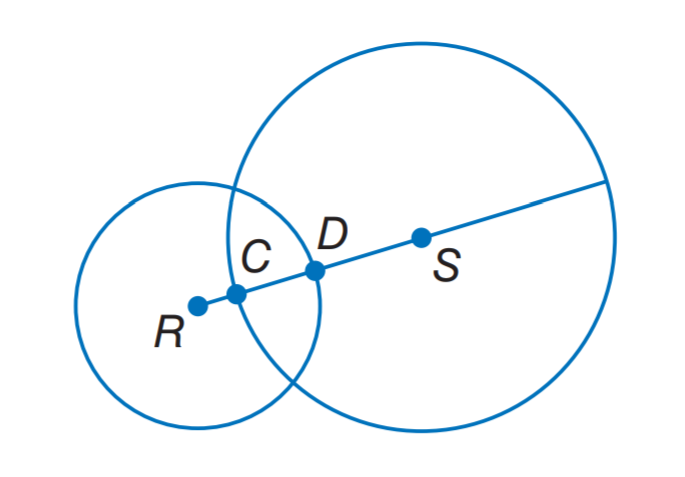Answer the mathemtical geometry problem and directly provide the correct option letter.
Question: The diameter of \odot S is 30 units, the diameter of \odot R is 20 units, and D S = 9 units. Find C D.
Choices: A: 4 B: 6 C: 9 D: 12 B 